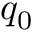<formula> <loc_0><loc_0><loc_500><loc_500>q _ { 0 }</formula> 